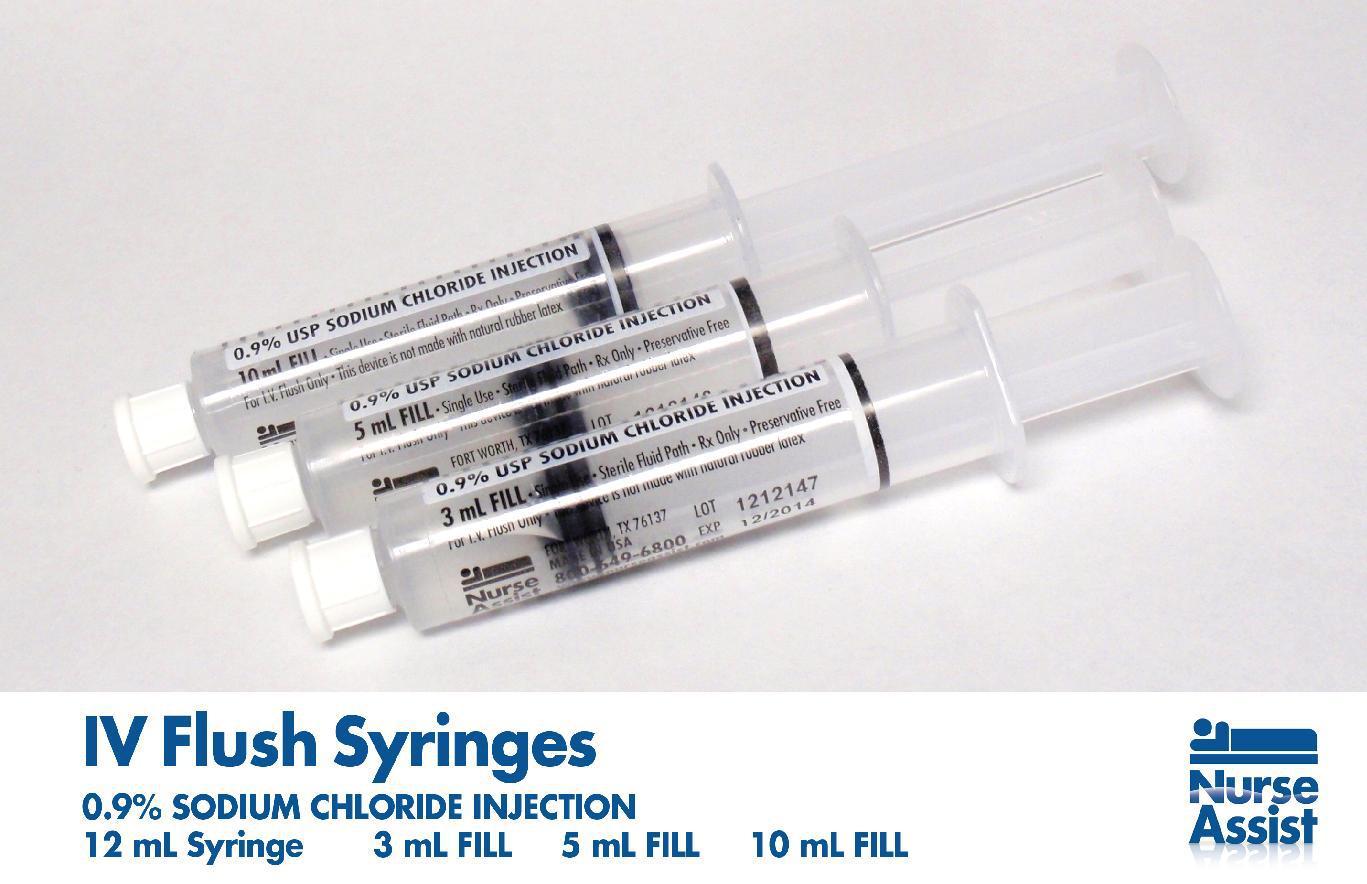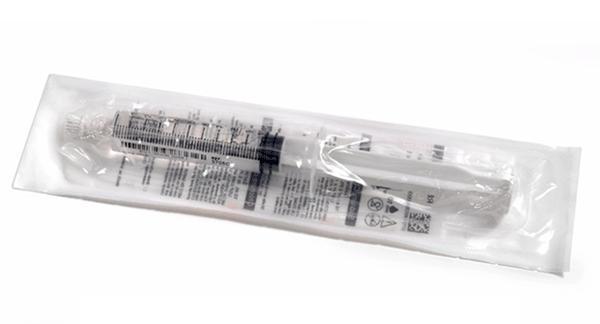The first image is the image on the left, the second image is the image on the right. Analyze the images presented: Is the assertion "The right image shows a single syringe." valid? Answer yes or no. Yes. 